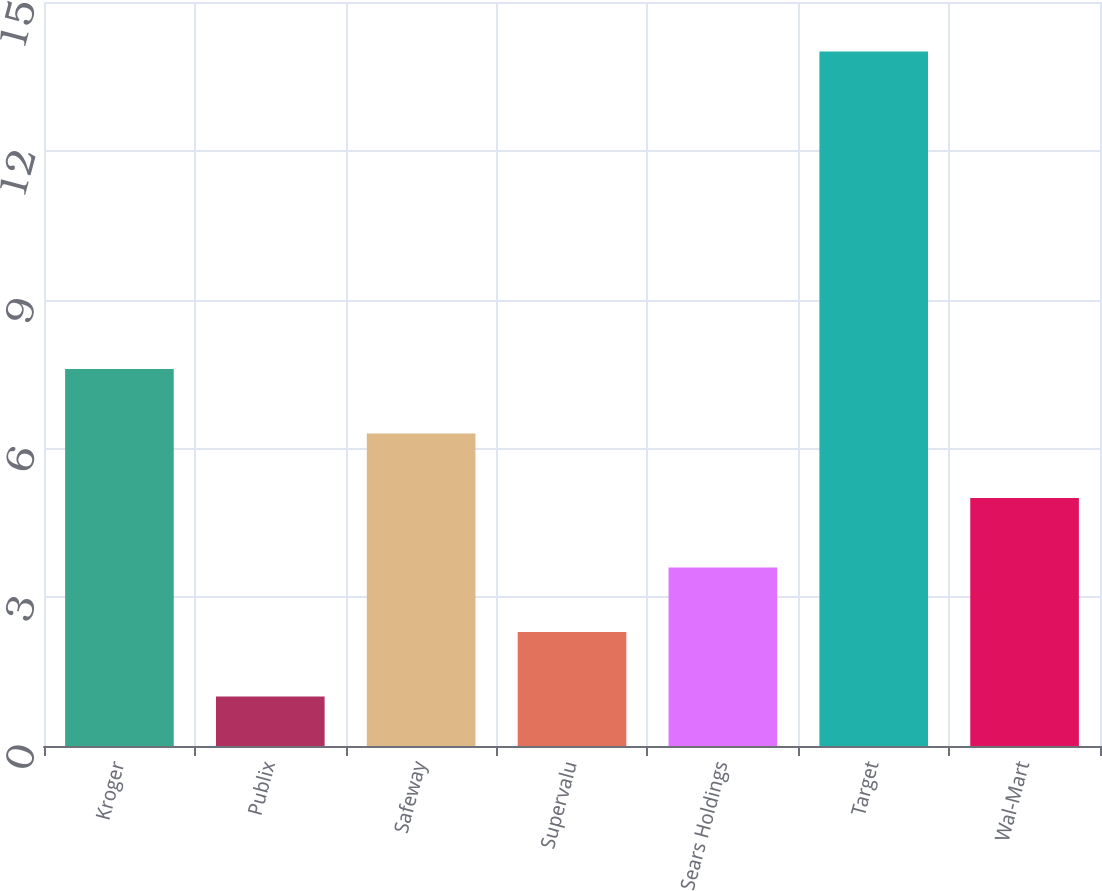Convert chart to OTSL. <chart><loc_0><loc_0><loc_500><loc_500><bar_chart><fcel>Kroger<fcel>Publix<fcel>Safeway<fcel>Supervalu<fcel>Sears Holdings<fcel>Target<fcel>Wal-Mart<nl><fcel>7.6<fcel>1<fcel>6.3<fcel>2.3<fcel>3.6<fcel>14<fcel>5<nl></chart> 